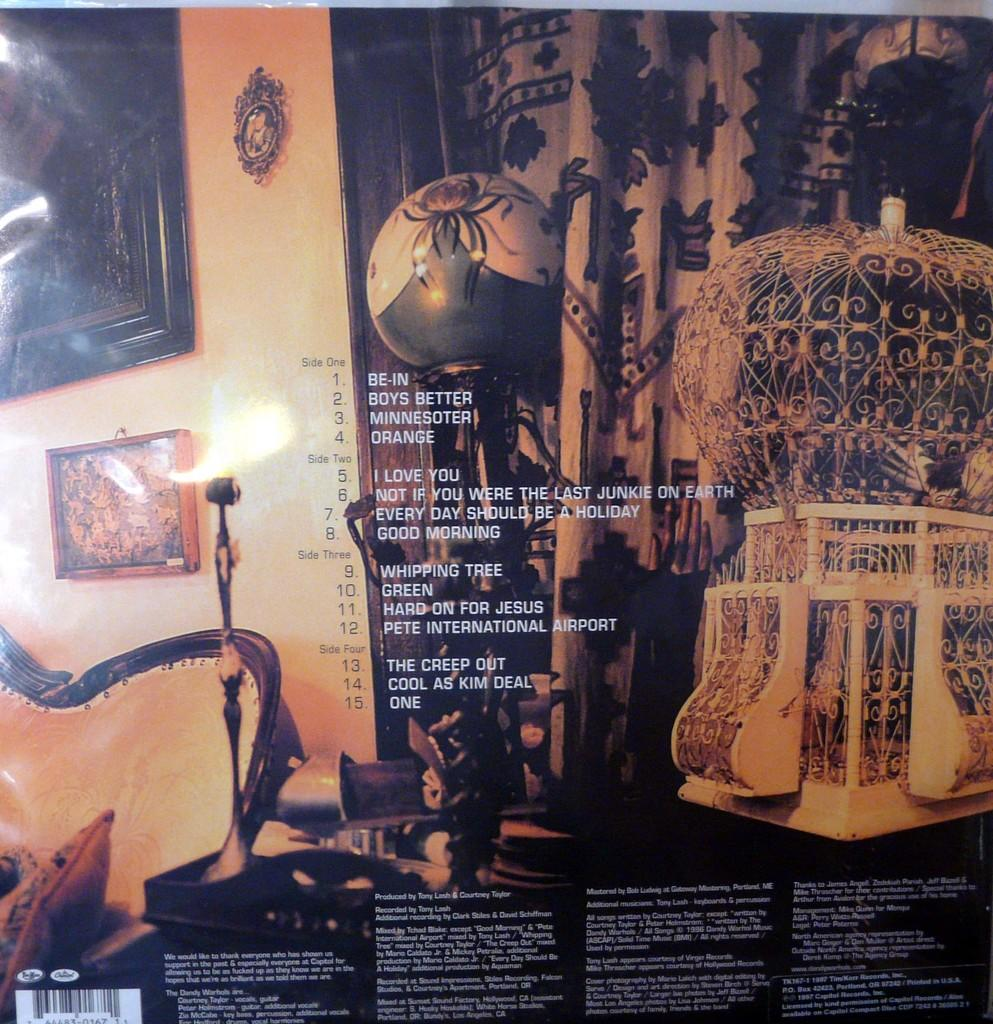<image>
Render a clear and concise summary of the photo. The back cover of an LP has a very art deco feel to it, and lists the first song on the first side as Be-In. 